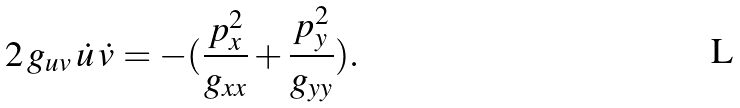Convert formula to latex. <formula><loc_0><loc_0><loc_500><loc_500>2 \, g _ { u v } \, \dot { u } \, \dot { v } = - ( { \frac { p _ { x } ^ { 2 } } { g _ { x x } } } + { \frac { p _ { y } ^ { 2 } } { g _ { y y } } } ) .</formula> 